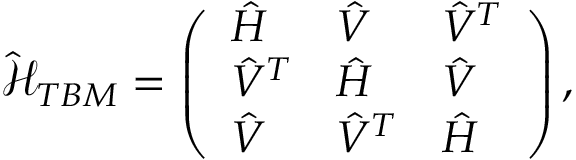<formula> <loc_0><loc_0><loc_500><loc_500>\mathcal { \hat { H } } _ { T B M } = \left ( \begin{array} { l l l } { \hat { H } } & { \hat { V } } & { \hat { V } ^ { T } } \\ { \hat { V } ^ { T } } & { \hat { H } } & { \hat { V } } \\ { \hat { V } } & { \hat { V } ^ { T } } & { \hat { H } } \end{array} \right ) ,</formula> 